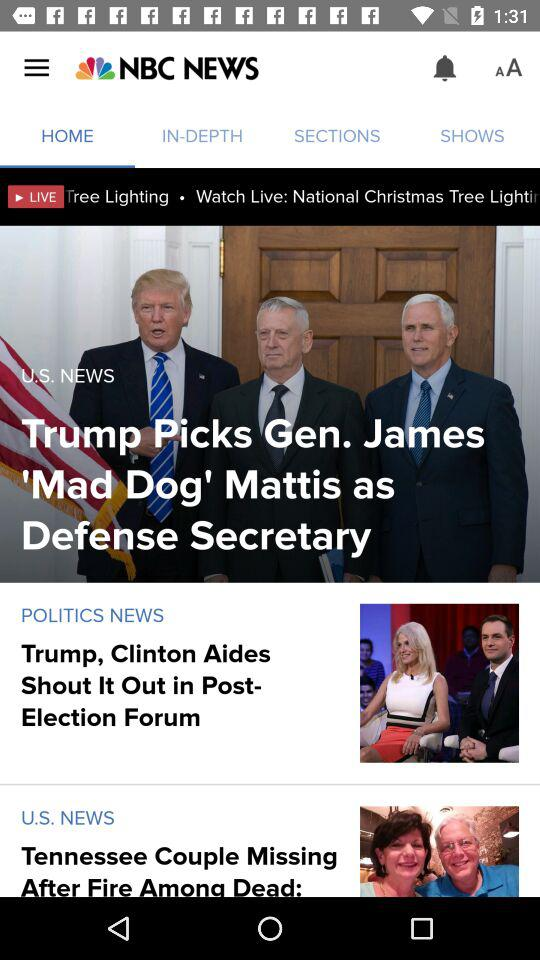What is the news channel name? The news channel name is "NBC NEWS". 